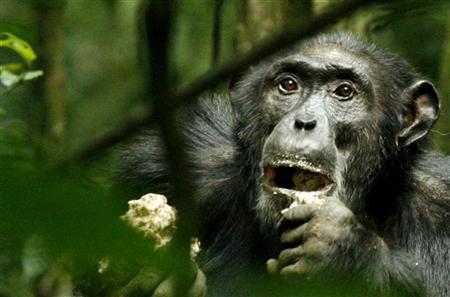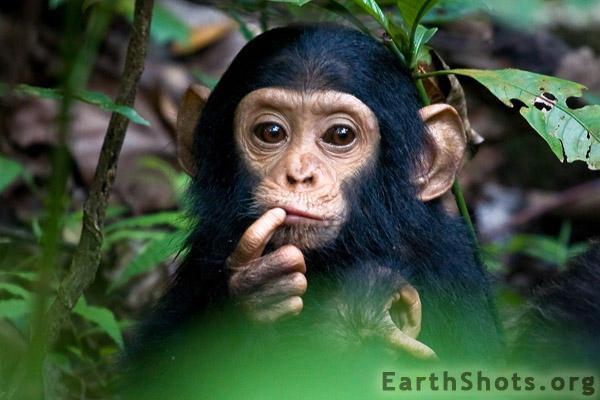The first image is the image on the left, the second image is the image on the right. Given the left and right images, does the statement "One of the images contains a monkey that is holding its finger on its mouth." hold true? Answer yes or no. Yes. 